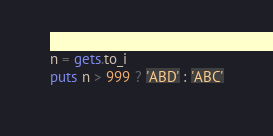Convert code to text. <code><loc_0><loc_0><loc_500><loc_500><_Ruby_>n = gets.to_i
puts n > 999 ? 'ABD' : 'ABC'</code> 